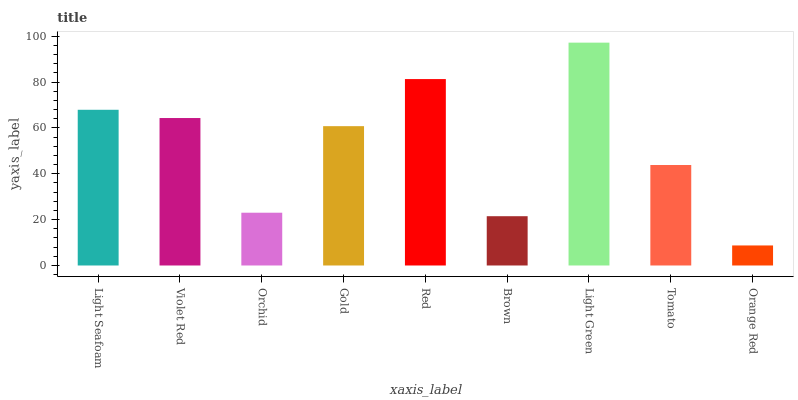Is Orange Red the minimum?
Answer yes or no. Yes. Is Light Green the maximum?
Answer yes or no. Yes. Is Violet Red the minimum?
Answer yes or no. No. Is Violet Red the maximum?
Answer yes or no. No. Is Light Seafoam greater than Violet Red?
Answer yes or no. Yes. Is Violet Red less than Light Seafoam?
Answer yes or no. Yes. Is Violet Red greater than Light Seafoam?
Answer yes or no. No. Is Light Seafoam less than Violet Red?
Answer yes or no. No. Is Gold the high median?
Answer yes or no. Yes. Is Gold the low median?
Answer yes or no. Yes. Is Orchid the high median?
Answer yes or no. No. Is Brown the low median?
Answer yes or no. No. 